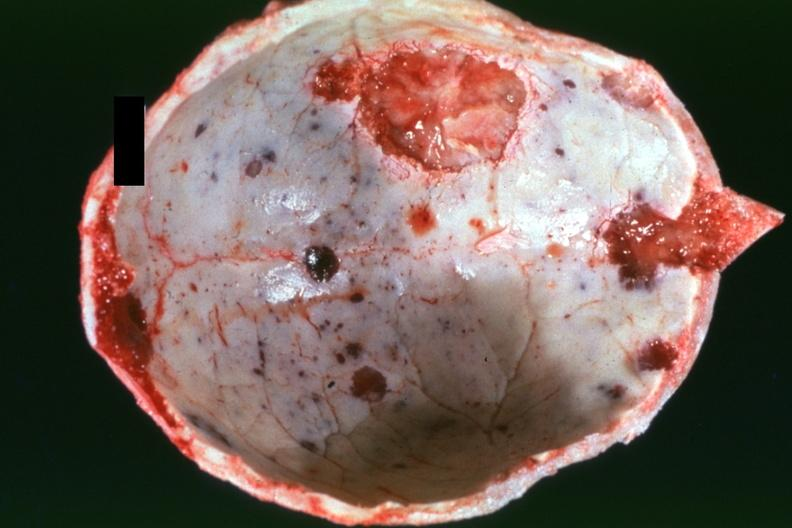s granulosa cell tumor present?
Answer the question using a single word or phrase. No 